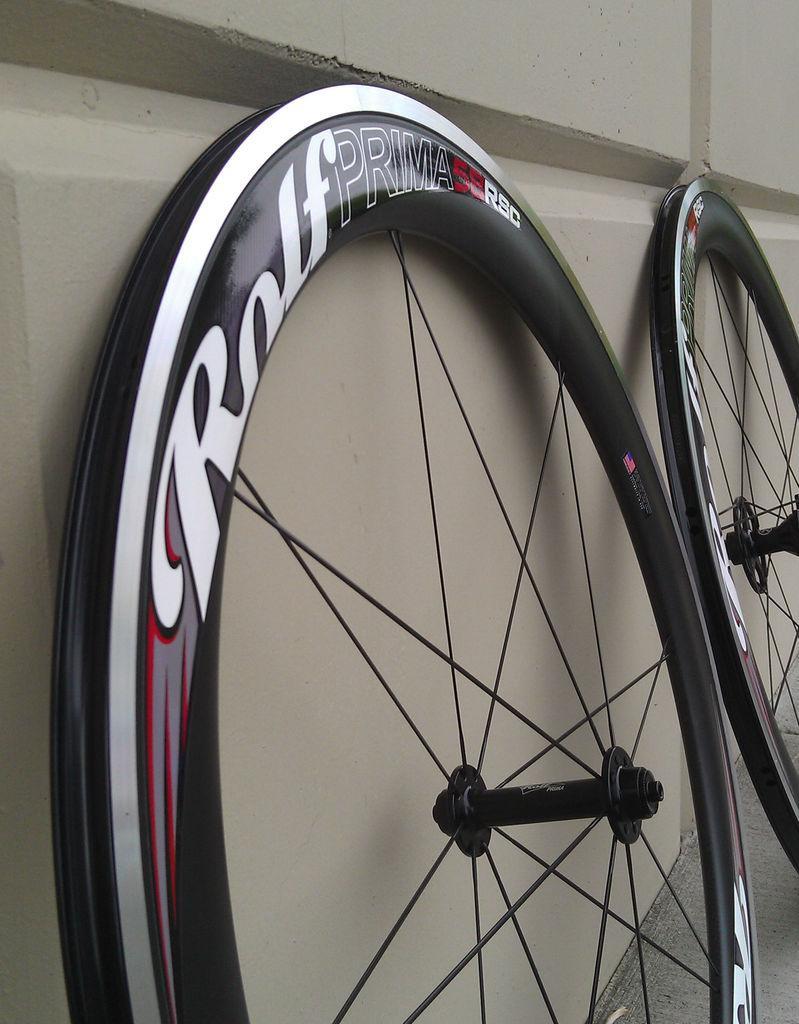Could you give a brief overview of what you see in this image? In this image there are two wheels on the wheels there is text, and there is a wall. At the bottom there is floor. 